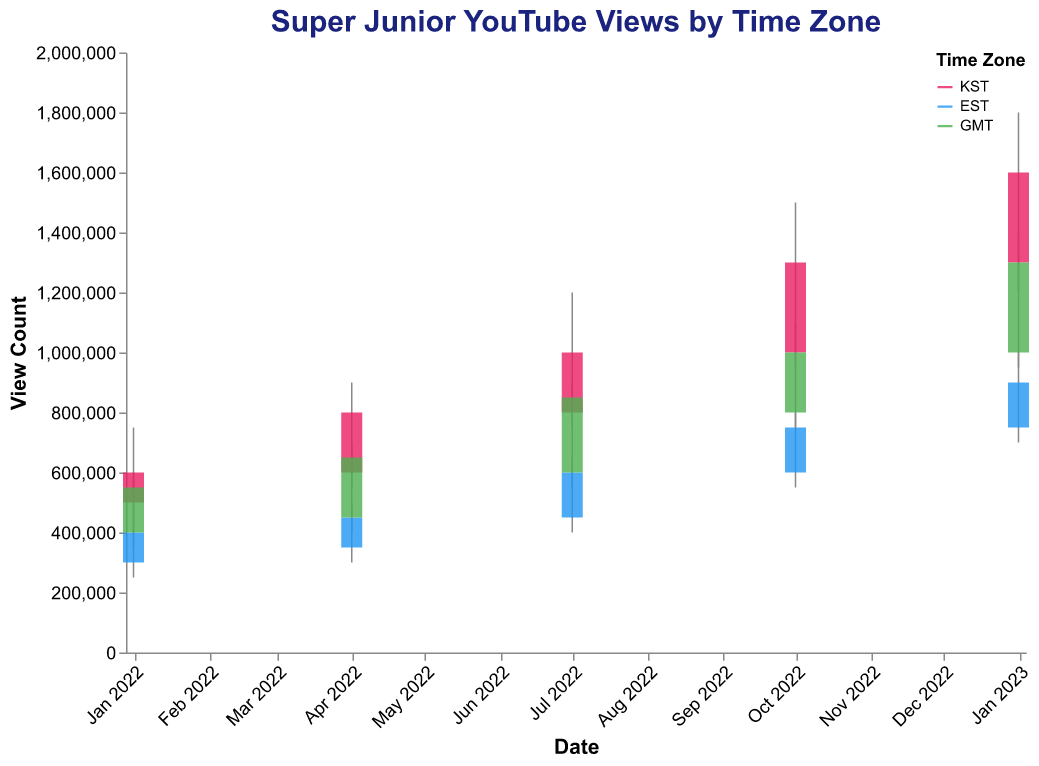What is the title of the figure? The title is typically placed at the top of the figure and gives an idea of what the chart represents. In this case, it is "Super Junior YouTube Views by Time Zone," which indicates that the chart shows YouTube views of Super Junior's music videos segmented by time zones.
Answer: Super Junior YouTube Views by Time Zone How many time zones are represented in the figure? The legend on the right side of the figure displays the different time zones. There are three time zones listed: KST (Korea Standard Time), EST (Eastern Standard Time), and GMT (Greenwich Mean Time).
Answer: 3 Which date and time zone combination had the highest closing view count? We need to find the highest "Close" value among all dates and time zones. The highest closing view count is 1,600,000 on January 1, 2023, in the KST time zone.
Answer: January 1, 2023, KST On which date did the EST time zone have the highest high view count and what was the value? By examining the "High" view counts for the EST time zone, the highest occurs on January 1, 2023, and the value is 1,000,000.
Answer: January 1, 2023; 1,000,000 What is the trend in closing view counts for KST time zone from January 1, 2022, to January 1, 2023? To analyze the trend, we examine the "Close" values for the KST time zone on the given dates. The values are 600,000 (Jan 1, 2022), 800,000 (Apr 1, 2022), 1,000,000 (Jul 1, 2022), 1,300,000 (Oct 1, 2022), and 1,600,000 (Jan 1, 2023). The trend indicates a consistent increase in closing view counts.
Answer: Increasing How do the high view counts for GMT and KST compare on July 1, 2022? Checking the high view count values for July 1, 2022, for GMT and KST, we find that KST has a value of 1,200,000, while GMT has a value of 900,000. Thus, KST has higher high view counts compared to GMT on this date.
Answer: KST higher What is the average opening view count across all time zones on October 1, 2022? The opening view counts on October 1, 2022, are: KST (1,000,000), EST (600,000), and GMT (800,000). Average = (1,000,000 + 600,000 + 800,000)/3 = 2,400,000/3 = 800,000
Answer: 800,000 Which time zone had the most significant increase in closing view count from April 1, 2022, to July 1, 2022? We compare the closing view counts: KST (from 800,000 to 1,000,000), EST (from 450,000 to 600,000), and GMT (from 650,000 to 850,000). The change amounts are: KST = 200,000, EST = 150,000, GMT = 200,000. Both KST and GMT had the most significant increase of 200,000.
Answer: KST and GMT What was the lowest low view count across all time zones on January 1, 2022? The low view counts on January 1, 2022, are: KST (450,000), EST (250,000), and GMT (350,000). The lowest value among these is 250,000 from the EST time zone.
Answer: 250,000 